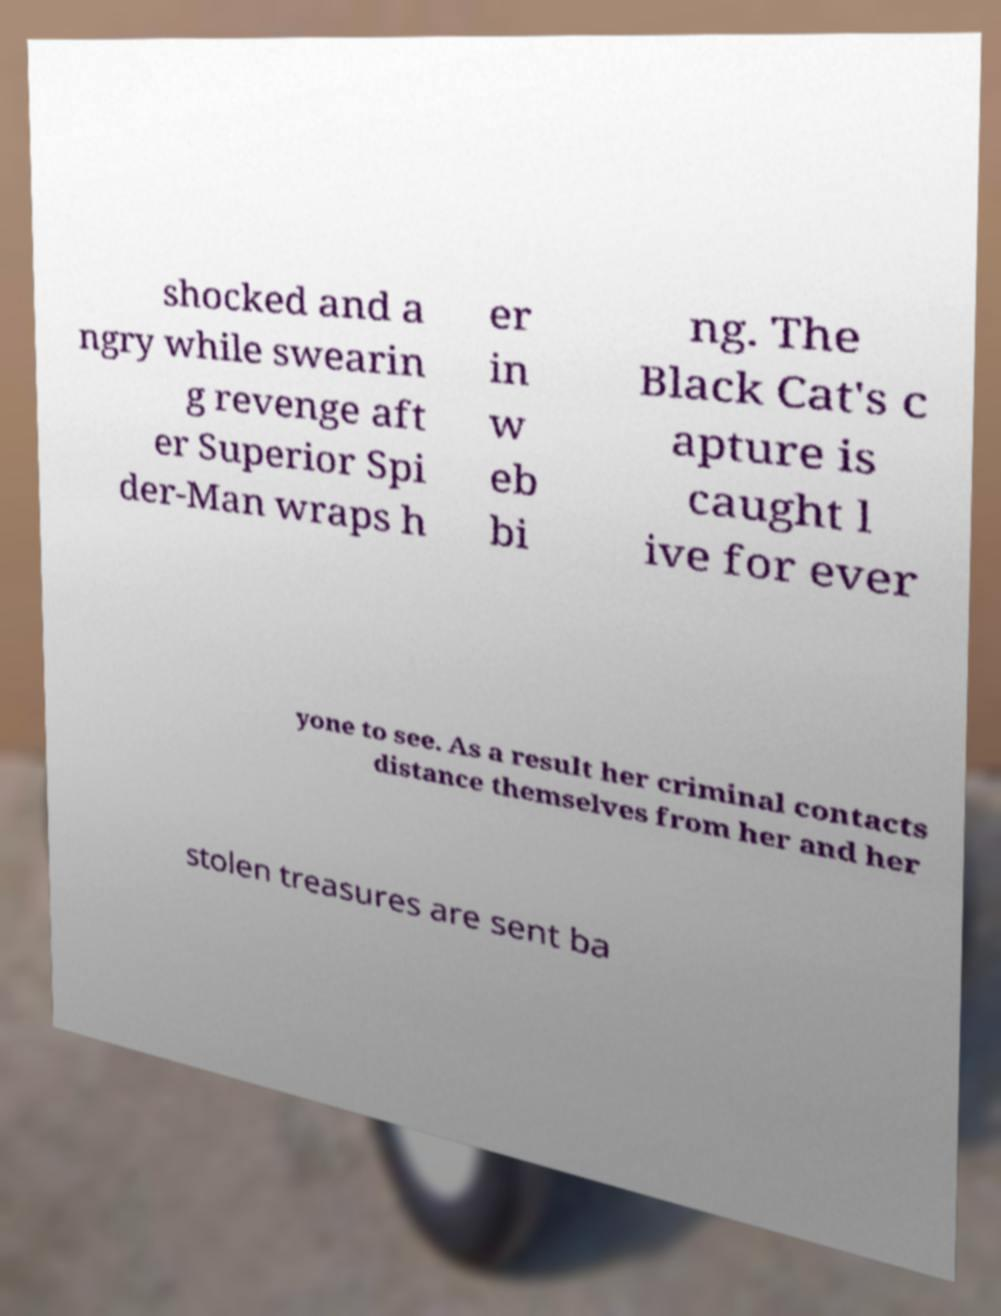There's text embedded in this image that I need extracted. Can you transcribe it verbatim? shocked and a ngry while swearin g revenge aft er Superior Spi der-Man wraps h er in w eb bi ng. The Black Cat's c apture is caught l ive for ever yone to see. As a result her criminal contacts distance themselves from her and her stolen treasures are sent ba 